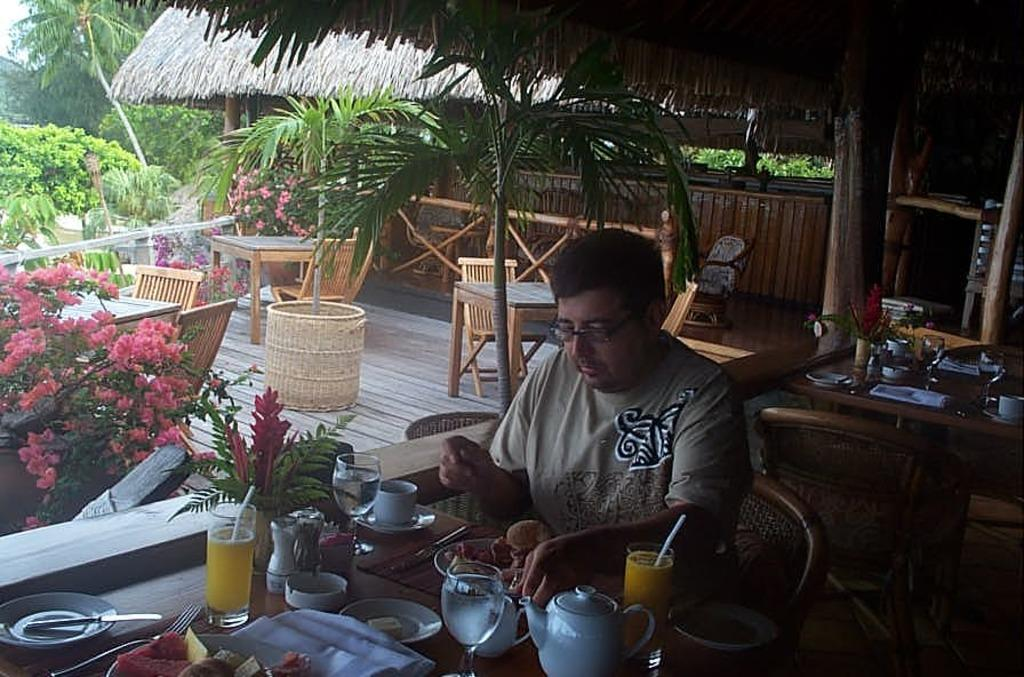What is the person in the image doing? The person is having food and drinks. What is the person wearing in the image? The person is wearing a T-shirt. What can be seen in the background of the image? There are plants, trees, tables, and a hut in the background of the image. What type of vegetable is being used to clear the person's throat in the image? There is no vegetable or throat-clearing activity depicted in the image. How many icicles can be seen hanging from the hut in the image? There are no icicles present in the image; it is not a winter scene. 